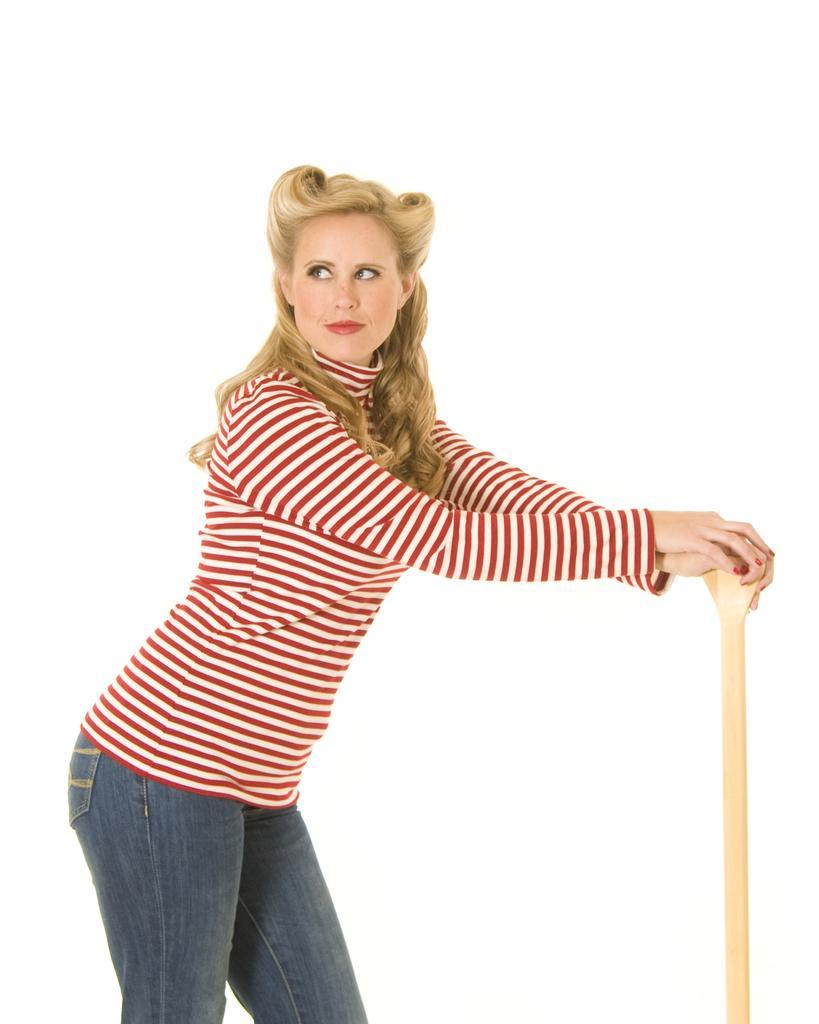How would you summarize this image in a sentence or two? In this picture I can see a woman in the middle, she is wearing a t-shirt, and trouser and also holding an object. 